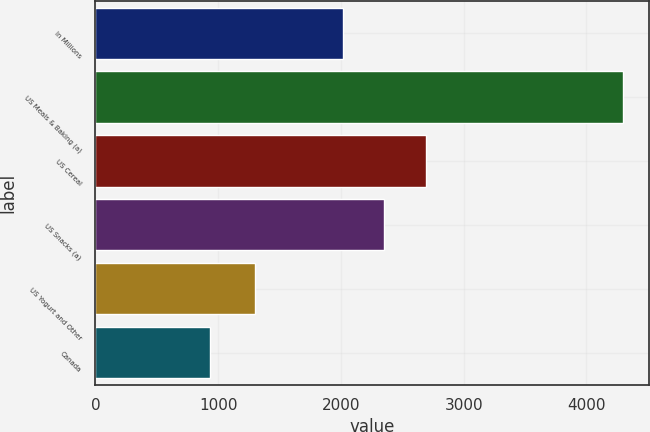<chart> <loc_0><loc_0><loc_500><loc_500><bar_chart><fcel>In Millions<fcel>US Meals & Baking (a)<fcel>US Cereal<fcel>US Snacks (a)<fcel>US Yogurt and Other<fcel>Canada<nl><fcel>2016<fcel>4297.3<fcel>2689.56<fcel>2352.78<fcel>1302.7<fcel>929.5<nl></chart> 